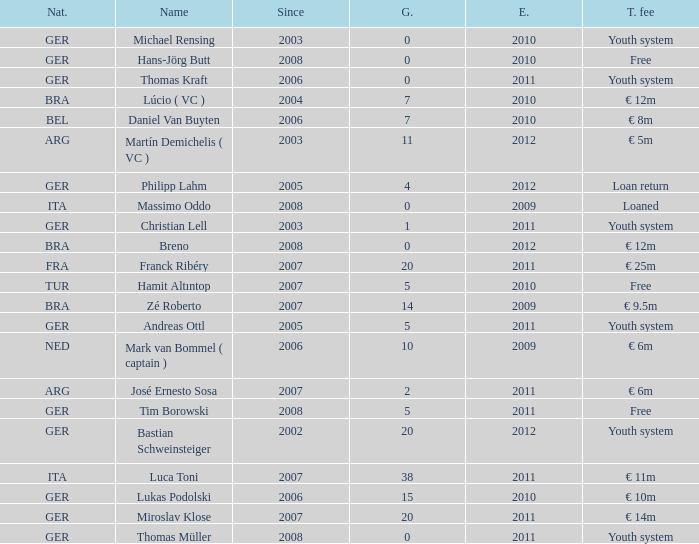What is the total number of ends after 2006 with a nationality of ita and 0 goals? 0.0. 